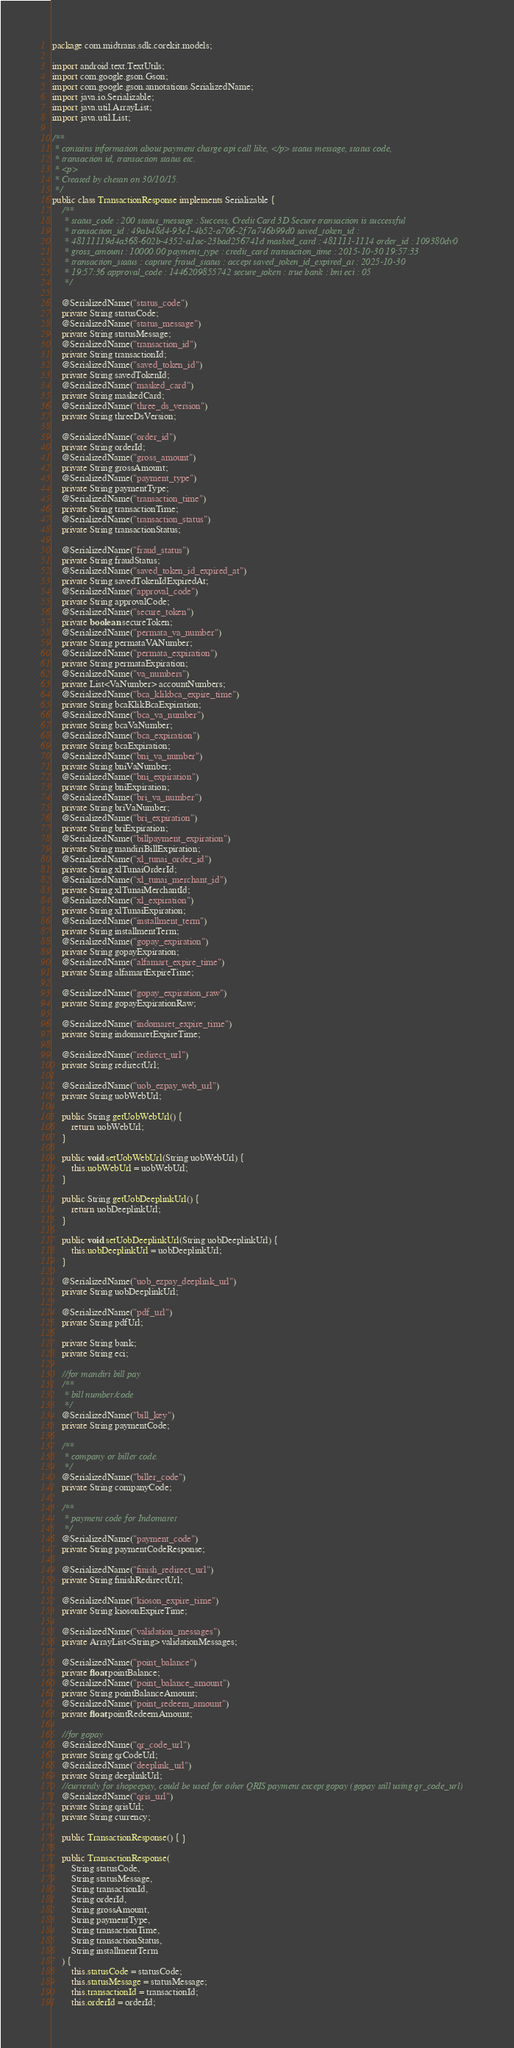<code> <loc_0><loc_0><loc_500><loc_500><_Java_>package com.midtrans.sdk.corekit.models;

import android.text.TextUtils;
import com.google.gson.Gson;
import com.google.gson.annotations.SerializedName;
import java.io.Serializable;
import java.util.ArrayList;
import java.util.List;

/**
 * contains information about payment charge api call like, </p> status message, status code,
 * transaction id, transaction status etc.
 * <p>
 * Created by chetan on 30/10/15.
 */
public class TransactionResponse implements Serializable {
    /**
     * status_code : 200 status_message : Success, Credit Card 3D Secure transaction is successful
     * transaction_id : 49ab48d4-93e1-4b52-a706-2f7a746b99d0 saved_token_id :
     * 48111119d4a368-602b-4352-a1ac-23bad256741d masked_card : 481111-1114 order_id : 109380dv0
     * gross_amount : 10000.00 payment_type : credit_card transaction_time : 2015-10-30 19:57:33
     * transaction_status : capture fraud_status : accept saved_token_id_expired_at : 2025-10-30
     * 19:57:36 approval_code : 1446209855742 secure_token : true bank : bni eci : 05
     */

    @SerializedName("status_code")
    private String statusCode;
    @SerializedName("status_message")
    private String statusMessage;
    @SerializedName("transaction_id")
    private String transactionId;
    @SerializedName("saved_token_id")
    private String savedTokenId;
    @SerializedName("masked_card")
    private String maskedCard;
    @SerializedName("three_ds_version")
    private String threeDsVersion;

    @SerializedName("order_id")
    private String orderId;
    @SerializedName("gross_amount")
    private String grossAmount;
    @SerializedName("payment_type")
    private String paymentType;
    @SerializedName("transaction_time")
    private String transactionTime;
    @SerializedName("transaction_status")
    private String transactionStatus;

    @SerializedName("fraud_status")
    private String fraudStatus;
    @SerializedName("saved_token_id_expired_at")
    private String savedTokenIdExpiredAt;
    @SerializedName("approval_code")
    private String approvalCode;
    @SerializedName("secure_token")
    private boolean secureToken;
    @SerializedName("permata_va_number")
    private String permataVANumber;
    @SerializedName("permata_expiration")
    private String permataExpiration;
    @SerializedName("va_numbers")
    private List<VaNumber> accountNumbers;
    @SerializedName("bca_klikbca_expire_time")
    private String bcaKlikBcaExpiration;
    @SerializedName("bca_va_number")
    private String bcaVaNumber;
    @SerializedName("bca_expiration")
    private String bcaExpiration;
    @SerializedName("bni_va_number")
    private String bniVaNumber;
    @SerializedName("bni_expiration")
    private String bniExpiration;
    @SerializedName("bri_va_number")
    private String briVaNumber;
    @SerializedName("bri_expiration")
    private String briExpiration;
    @SerializedName("billpayment_expiration")
    private String mandiriBillExpiration;
    @SerializedName("xl_tunai_order_id")
    private String xlTunaiOrderId;
    @SerializedName("xl_tunai_merchant_id")
    private String xlTunaiMerchantId;
    @SerializedName("xl_expiration")
    private String xlTunaiExpiration;
    @SerializedName("installment_term")
    private String installmentTerm;
    @SerializedName("gopay_expiration")
    private String gopayExpiration;
    @SerializedName("alfamart_expire_time")
    private String alfamartExpireTime;

    @SerializedName("gopay_expiration_raw")
    private String gopayExpirationRaw;

    @SerializedName("indomaret_expire_time")
    private String indomaretExpireTime;

    @SerializedName("redirect_url")
    private String redirectUrl;

    @SerializedName("uob_ezpay_web_url")
    private String uobWebUrl;

    public String getUobWebUrl() {
        return uobWebUrl;
    }

    public void setUobWebUrl(String uobWebUrl) {
        this.uobWebUrl = uobWebUrl;
    }

    public String getUobDeeplinkUrl() {
        return uobDeeplinkUrl;
    }

    public void setUobDeeplinkUrl(String uobDeeplinkUrl) {
        this.uobDeeplinkUrl = uobDeeplinkUrl;
    }

    @SerializedName("uob_ezpay_deeplink_url")
    private String uobDeeplinkUrl;

    @SerializedName("pdf_url")
    private String pdfUrl;

    private String bank;
    private String eci;

    //for mandiri bill pay
    /**
     * bill number/code
     */
    @SerializedName("bill_key")
    private String paymentCode;

    /**
     * company or biller code.
     */
    @SerializedName("biller_code")
    private String companyCode;

    /**
     * payment code for Indomaret
     */
    @SerializedName("payment_code")
    private String paymentCodeResponse;

    @SerializedName("finish_redirect_url")
    private String finishRedirectUrl;

    @SerializedName("kioson_expire_time")
    private String kiosonExpireTime;

    @SerializedName("validation_messages")
    private ArrayList<String> validationMessages;

    @SerializedName("point_balance")
    private float pointBalance;
    @SerializedName("point_balance_amount")
    private String pointBalanceAmount;
    @SerializedName("point_redeem_amount")
    private float pointRedeemAmount;

    //for gopay
    @SerializedName("qr_code_url")
    private String qrCodeUrl;
    @SerializedName("deeplink_url")
    private String deeplinkUrl;
    //currently for shopeepay, could be used for other QRIS payment except gopay (gopay still using qr_code_url)
    @SerializedName("qris_url")
    private String qrisUrl;
    private String currency;

    public TransactionResponse() { }

    public TransactionResponse(
        String statusCode,
        String statusMessage,
        String transactionId,
        String orderId,
        String grossAmount,
        String paymentType,
        String transactionTime,
        String transactionStatus,
        String installmentTerm
    ) {
        this.statusCode = statusCode;
        this.statusMessage = statusMessage;
        this.transactionId = transactionId;
        this.orderId = orderId;</code> 